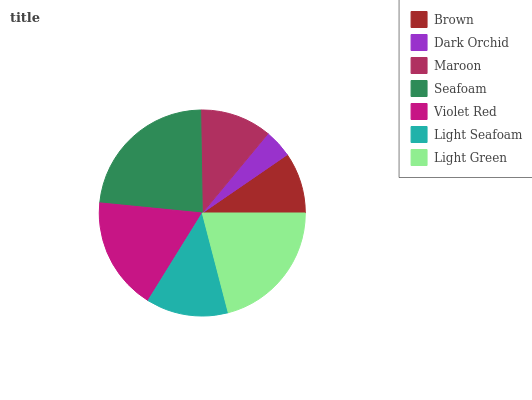Is Dark Orchid the minimum?
Answer yes or no. Yes. Is Seafoam the maximum?
Answer yes or no. Yes. Is Maroon the minimum?
Answer yes or no. No. Is Maroon the maximum?
Answer yes or no. No. Is Maroon greater than Dark Orchid?
Answer yes or no. Yes. Is Dark Orchid less than Maroon?
Answer yes or no. Yes. Is Dark Orchid greater than Maroon?
Answer yes or no. No. Is Maroon less than Dark Orchid?
Answer yes or no. No. Is Light Seafoam the high median?
Answer yes or no. Yes. Is Light Seafoam the low median?
Answer yes or no. Yes. Is Seafoam the high median?
Answer yes or no. No. Is Maroon the low median?
Answer yes or no. No. 